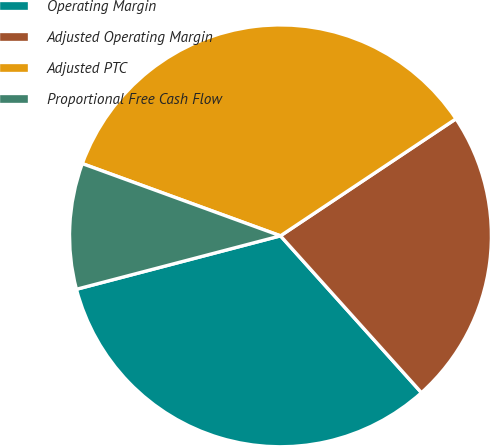Convert chart. <chart><loc_0><loc_0><loc_500><loc_500><pie_chart><fcel>Operating Margin<fcel>Adjusted Operating Margin<fcel>Adjusted PTC<fcel>Proportional Free Cash Flow<nl><fcel>32.58%<fcel>22.71%<fcel>35.08%<fcel>9.64%<nl></chart> 